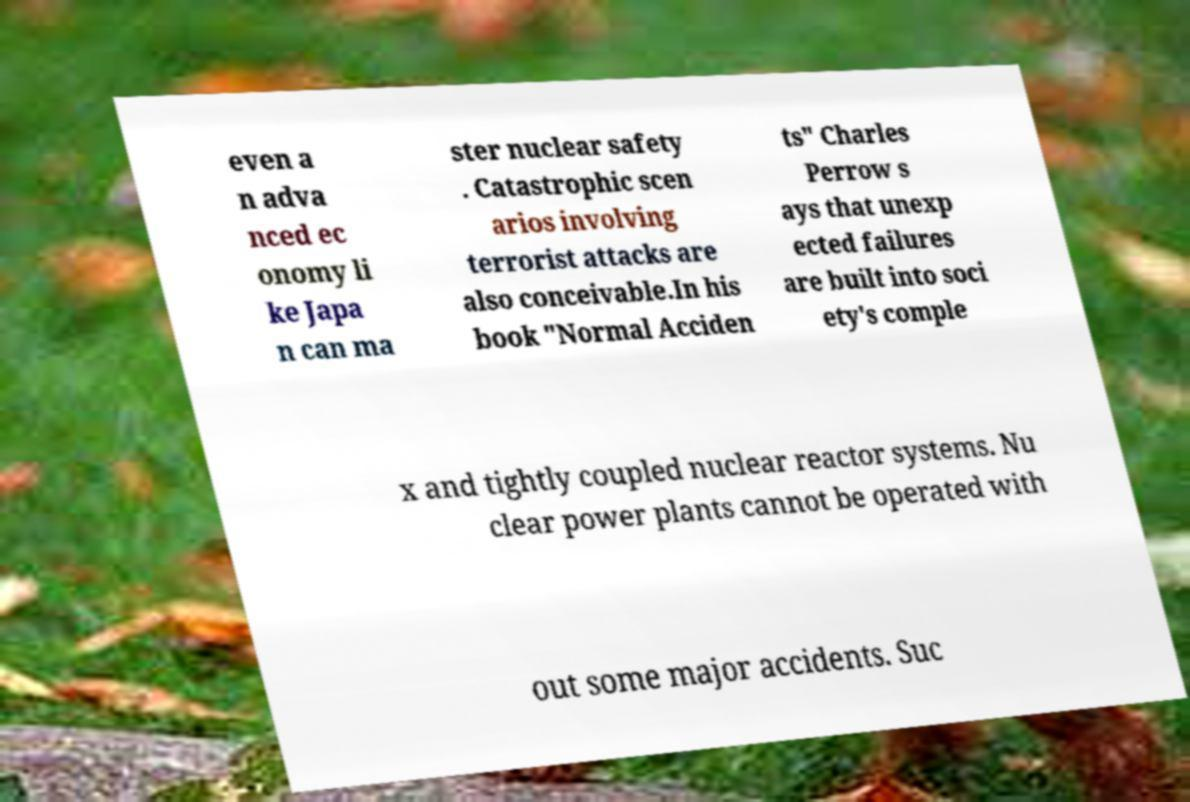Can you read and provide the text displayed in the image?This photo seems to have some interesting text. Can you extract and type it out for me? even a n adva nced ec onomy li ke Japa n can ma ster nuclear safety . Catastrophic scen arios involving terrorist attacks are also conceivable.In his book "Normal Acciden ts" Charles Perrow s ays that unexp ected failures are built into soci ety's comple x and tightly coupled nuclear reactor systems. Nu clear power plants cannot be operated with out some major accidents. Suc 